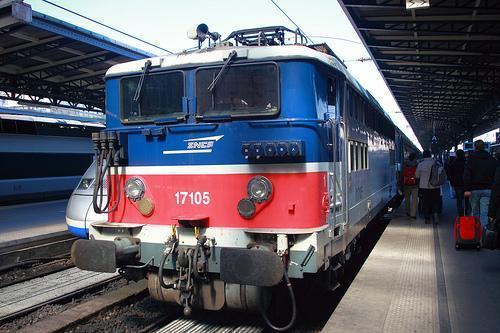How many green trains are there?
Give a very brief answer. 0. 